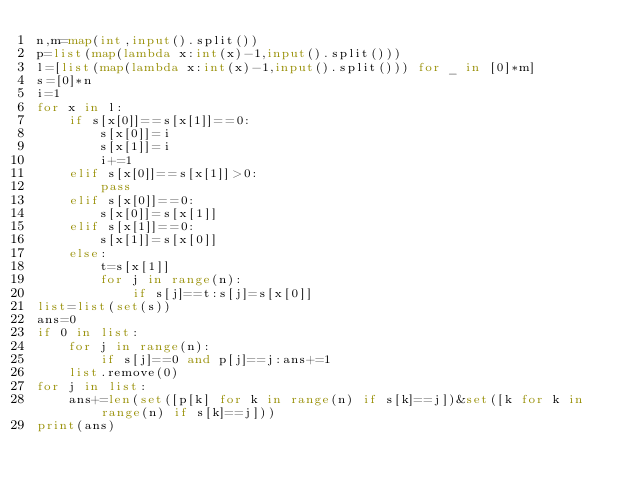Convert code to text. <code><loc_0><loc_0><loc_500><loc_500><_Python_>n,m=map(int,input().split())
p=list(map(lambda x:int(x)-1,input().split()))
l=[list(map(lambda x:int(x)-1,input().split())) for _ in [0]*m]
s=[0]*n
i=1
for x in l:
    if s[x[0]]==s[x[1]]==0:
        s[x[0]]=i
        s[x[1]]=i
        i+=1
    elif s[x[0]]==s[x[1]]>0:
        pass
    elif s[x[0]]==0:
        s[x[0]]=s[x[1]]
    elif s[x[1]]==0:
        s[x[1]]=s[x[0]]
    else:
        t=s[x[1]]
        for j in range(n):
            if s[j]==t:s[j]=s[x[0]]
list=list(set(s))
ans=0
if 0 in list:
    for j in range(n):
        if s[j]==0 and p[j]==j:ans+=1
    list.remove(0)
for j in list:
    ans+=len(set([p[k] for k in range(n) if s[k]==j])&set([k for k in range(n) if s[k]==j]))
print(ans)</code> 